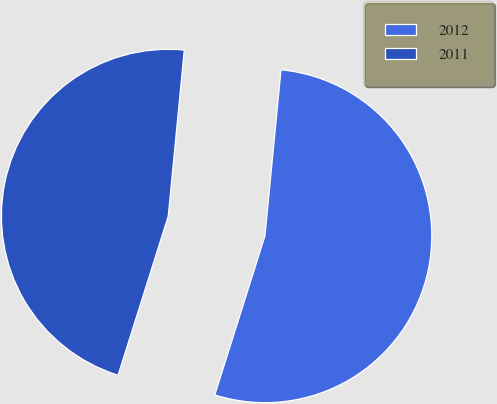<chart> <loc_0><loc_0><loc_500><loc_500><pie_chart><fcel>2012<fcel>2011<nl><fcel>53.33%<fcel>46.67%<nl></chart> 